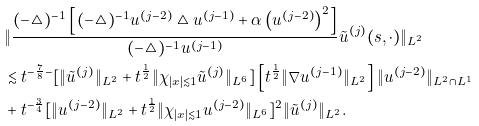Convert formula to latex. <formula><loc_0><loc_0><loc_500><loc_500>& \| \frac { ( - \triangle ) ^ { - 1 } \left [ ( - \triangle ) ^ { - 1 } u ^ { ( j - 2 ) } \triangle u ^ { ( j - 1 ) } + \alpha \left ( u ^ { ( j - 2 ) } \right ) ^ { 2 } \right ] } { ( - \triangle ) ^ { - 1 } u ^ { ( j - 1 ) } } \tilde { u } ^ { ( j ) } ( s , \cdot ) \| _ { L ^ { 2 } } \\ & \lesssim t ^ { - \frac { 7 } { 8 } - } [ \| \tilde { u } ^ { ( j ) } \| _ { L ^ { 2 } } + t ^ { \frac { 1 } { 2 } } \| \chi _ { | x | \lesssim 1 } \tilde { u } ^ { ( j ) } \| _ { L ^ { 6 } } ] \left [ t ^ { \frac { 1 } { 2 } } \| \nabla u ^ { ( j - 1 ) } \| _ { L ^ { 2 } } \right ] \| u ^ { ( j - 2 ) } \| _ { L ^ { 2 } \cap L ^ { 1 } } \\ & + t ^ { - \frac { 3 } { 4 } } [ \| u ^ { ( j - 2 ) } \| _ { L ^ { 2 } } + t ^ { \frac { 1 } { 2 } } \| \chi _ { | x | \lesssim 1 } u ^ { ( j - 2 ) } \| _ { L ^ { 6 } } ] ^ { 2 } \| \tilde { u } ^ { ( j ) } \| _ { L ^ { 2 } } .</formula> 